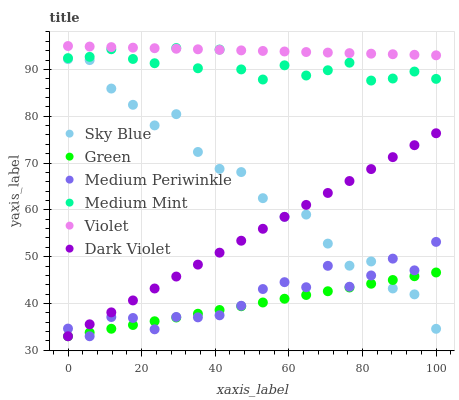Does Green have the minimum area under the curve?
Answer yes or no. Yes. Does Violet have the maximum area under the curve?
Answer yes or no. Yes. Does Medium Periwinkle have the minimum area under the curve?
Answer yes or no. No. Does Medium Periwinkle have the maximum area under the curve?
Answer yes or no. No. Is Violet the smoothest?
Answer yes or no. Yes. Is Sky Blue the roughest?
Answer yes or no. Yes. Is Medium Periwinkle the smoothest?
Answer yes or no. No. Is Medium Periwinkle the roughest?
Answer yes or no. No. Does Medium Periwinkle have the lowest value?
Answer yes or no. Yes. Does Violet have the lowest value?
Answer yes or no. No. Does Violet have the highest value?
Answer yes or no. Yes. Does Medium Periwinkle have the highest value?
Answer yes or no. No. Is Dark Violet less than Medium Mint?
Answer yes or no. Yes. Is Medium Mint greater than Medium Periwinkle?
Answer yes or no. Yes. Does Medium Periwinkle intersect Dark Violet?
Answer yes or no. Yes. Is Medium Periwinkle less than Dark Violet?
Answer yes or no. No. Is Medium Periwinkle greater than Dark Violet?
Answer yes or no. No. Does Dark Violet intersect Medium Mint?
Answer yes or no. No. 